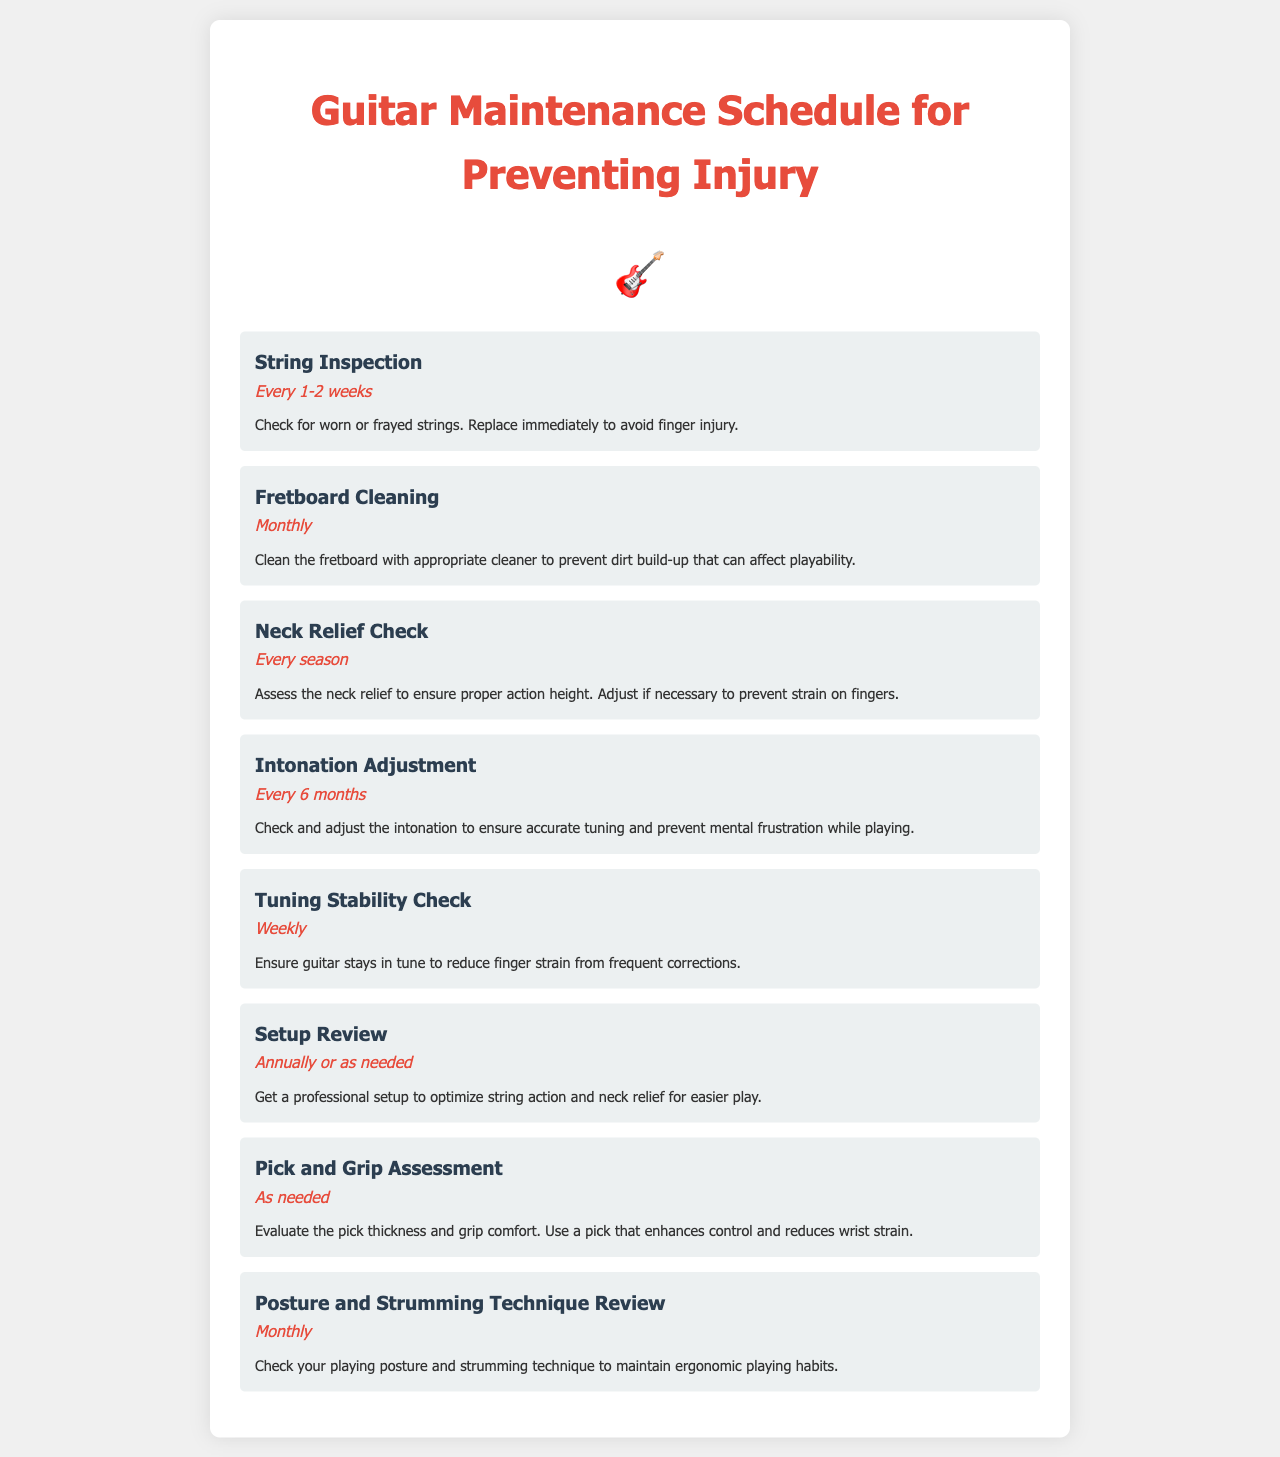what is the frequency of string inspection? The document states that string inspection should be performed every 1-2 weeks.
Answer: Every 1-2 weeks how often should you clean the fretboard? According to the document, the fretboard should be cleaned monthly.
Answer: Monthly what is the task associated with neck relief? The neck relief check is the task mentioned, which ensures proper action height.
Answer: Neck Relief Check how often should intonation adjustment be done? The document specifies that intonation adjustment should be done every 6 months.
Answer: Every 6 months what is the main purpose of the setup review? The setup review aims to optimize string action and neck relief for easier play.
Answer: Optimize string action and neck relief why is tuning stability important? Tuning stability is important to reduce finger strain from frequent corrections.
Answer: Reduce finger strain what should you evaluate during pick and grip assessment? The evaluation should focus on pick thickness and grip comfort.
Answer: Pick thickness and grip comfort when should you review posture and strumming technique? The document indicates that posture and strumming technique should be reviewed monthly.
Answer: Monthly 